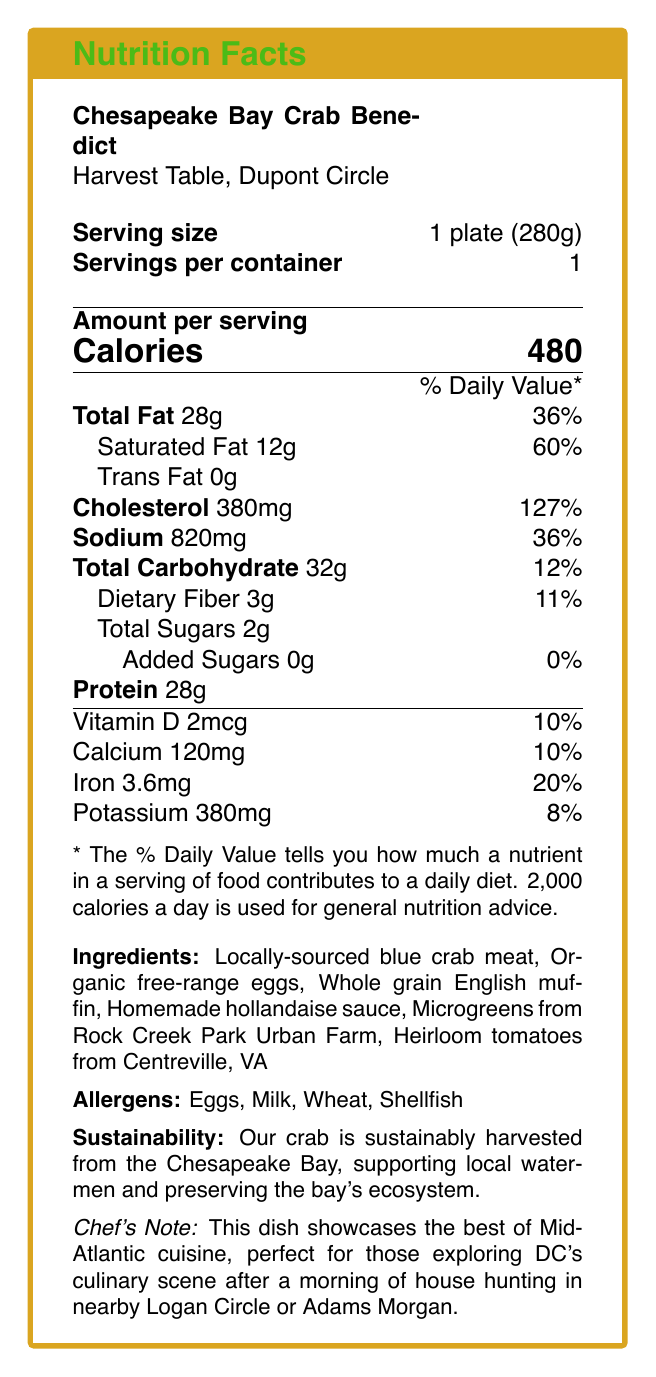what is the serving size for the Chesapeake Bay Crab Benedict? The document lists the serving size as "1 plate (280g)" directly under the dish name.
Answer: 1 plate (280g) what percentage of the daily value of cholesterol does this dish provide? Under the Cholesterol section, it states 380mg, which is 127% of the daily value.
Answer: 127% how many grams of protein are in one serving? The protein content per serving is listed as 28g.
Answer: 28g what are the allergens present in the dish? The allergens section lists Eggs, Milk, Wheat, and Shellfish.
Answer: Eggs, Milk, Wheat, Shellfish where are the heirloom tomatoes sourced from? The ingredient list specifies that the heirloom tomatoes are from Centreville, VA.
Answer: Centreville, VA which nutrient has the highest percentage of daily value? A. Sodium B. Saturated Fat C. Protein D. Cholesterol Cholesterol has the highest daily value at 127%, compared to others listed.
Answer: D. Cholesterol how many calories are in one serving of the Chesapeake Bay Crab Benedict? The amount per serving section lists the calories as 480.
Answer: 480 calories what key message does the chef's note convey? A. Information about the restaurant B. Invitation to visit the restaurant C. Culinary highlights and local recommendations D. Nutritional benefits of the dish The chef's note describes the dish as showcasing the best of Mid-Atlantic cuisine and mentions local culinary exploration.
Answer: C. Culinary highlights and local recommendations is the crab meat sustainably sourced? The sustainability info section mentions that the crab is sustainably harvested from the Chesapeake Bay.
Answer: Yes how many grams of total fat are in one serving? The total fat section lists 28g per serving.
Answer: 28g what information cannot be determined from the document? The document does not include any information about the price of the dish.
Answer: The price of the brunch dish summarize the main idea of the document. The document is designed to provide complete nutritional information and highlight the sourcing, sustainability, and culinary significance of the Chesapeake Bay Crab Benedict served at Harvest Table.
Answer: It's a Nutrition Facts Label for the Chesapeake Bay Crab Benedict dish served at Harvest Table, detailing its nutritional content, ingredients, allergens, and sustainability note, along with a chef's note about local culinary highlights. how much added sugar is in the dish? The total carbohydrate section lists added sugars as 0g.
Answer: 0g what amount of calcium does one serving provide? The micronutrient section lists calcium as 120mg, which is 10% of the daily value.
Answer: 120mg (10% Daily Value) does the dish contain any trans fat? The total fat section lists trans fat as 0g.
Answer: No name two of the farms or sources mentioned in the ingredients list. The microgreens are from Rock Creek Park Urban Farm and heirloom tomatoes from Centreville, VA.
Answer: Rock Creek Park Urban Farm and Centreville, VA 